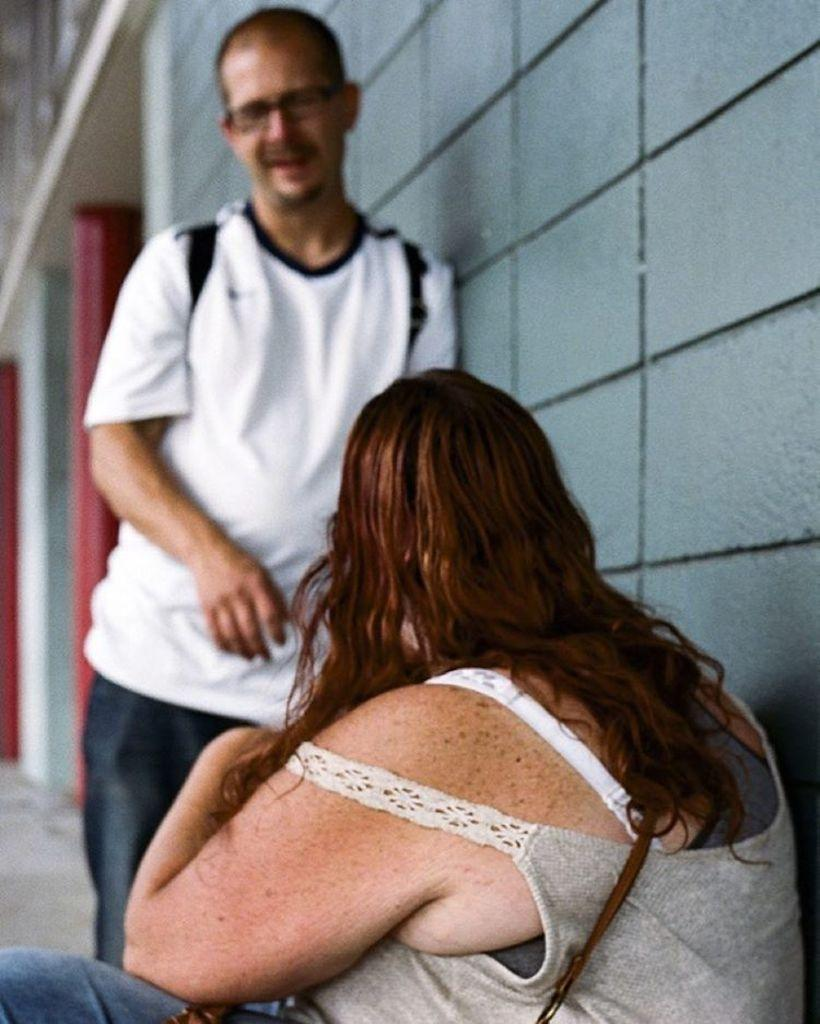How many people are present in the image? There are two people in the image. What can be seen in the background of the image? There is a wall in the background of the image. How many rabbits are visible in the image? There are no rabbits present in the image. What type of guide is assisting the two people in the image? There is no guide present in the image, and the two people are not interacting with anyone else. 